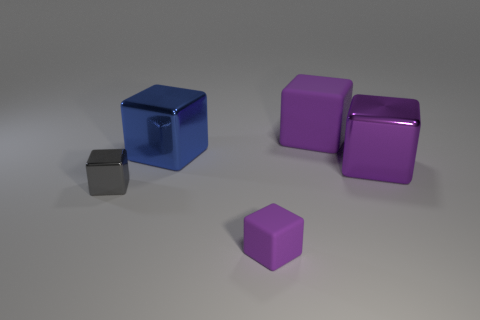What is the color of the other metallic cube that is the same size as the purple metal block?
Your response must be concise. Blue. What number of small gray metallic cubes are left of the big blue metallic object?
Your answer should be compact. 1. Are there any large blue cubes that have the same material as the large blue object?
Provide a succinct answer. No. There is a large shiny object that is the same color as the tiny matte block; what shape is it?
Provide a short and direct response. Cube. There is a matte object that is in front of the small shiny object; what color is it?
Offer a very short reply. Purple. Is the number of large rubber cubes that are on the right side of the purple metal thing the same as the number of big shiny cubes right of the small metallic object?
Offer a very short reply. No. The object that is to the right of the rubber object that is behind the tiny metal cube is made of what material?
Keep it short and to the point. Metal. How many things are purple metal things or tiny cubes that are in front of the gray metallic block?
Keep it short and to the point. 2. There is another purple cube that is made of the same material as the tiny purple block; what is its size?
Keep it short and to the point. Large. Is the number of gray blocks behind the large blue shiny cube greater than the number of big cylinders?
Your answer should be very brief. No. 